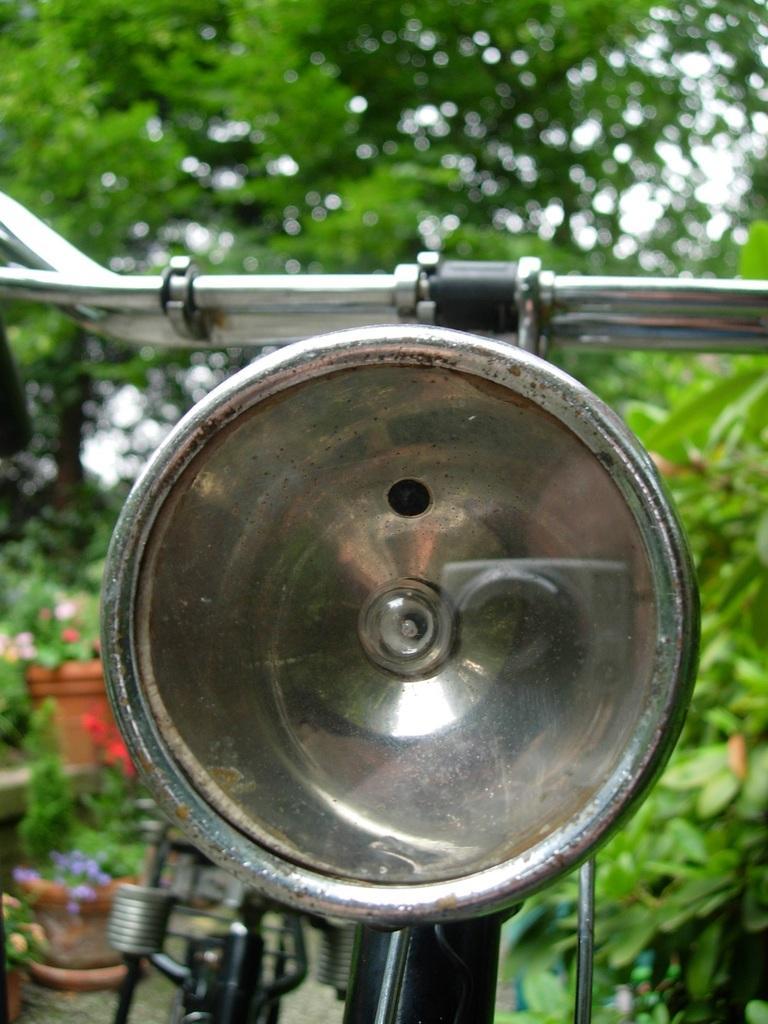Can you describe this image briefly? In this image I see a cycle and I see there are few plants over here and it is totally green in the background. 